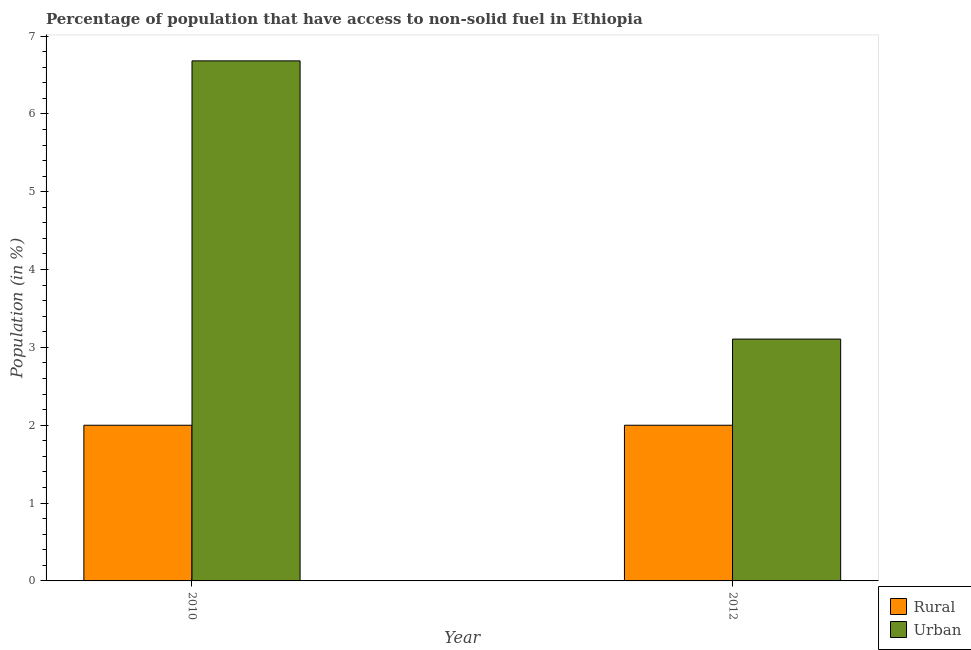How many groups of bars are there?
Offer a very short reply. 2. Are the number of bars per tick equal to the number of legend labels?
Keep it short and to the point. Yes. How many bars are there on the 2nd tick from the right?
Your response must be concise. 2. What is the urban population in 2010?
Offer a very short reply. 6.68. Across all years, what is the maximum rural population?
Provide a short and direct response. 2. Across all years, what is the minimum urban population?
Provide a succinct answer. 3.11. In which year was the rural population maximum?
Offer a terse response. 2010. What is the total urban population in the graph?
Offer a terse response. 9.79. What is the difference between the urban population in 2010 and that in 2012?
Keep it short and to the point. 3.57. What is the difference between the rural population in 2012 and the urban population in 2010?
Provide a short and direct response. 0. What is the average urban population per year?
Give a very brief answer. 4.89. In the year 2012, what is the difference between the rural population and urban population?
Your answer should be very brief. 0. What is the ratio of the urban population in 2010 to that in 2012?
Ensure brevity in your answer.  2.15. What does the 2nd bar from the left in 2012 represents?
Provide a succinct answer. Urban. What does the 1st bar from the right in 2010 represents?
Provide a succinct answer. Urban. Are all the bars in the graph horizontal?
Offer a terse response. No. Are the values on the major ticks of Y-axis written in scientific E-notation?
Provide a succinct answer. No. Does the graph contain grids?
Make the answer very short. No. Where does the legend appear in the graph?
Provide a succinct answer. Bottom right. How many legend labels are there?
Your answer should be compact. 2. How are the legend labels stacked?
Keep it short and to the point. Vertical. What is the title of the graph?
Your answer should be very brief. Percentage of population that have access to non-solid fuel in Ethiopia. What is the label or title of the Y-axis?
Provide a short and direct response. Population (in %). What is the Population (in %) in Rural in 2010?
Offer a terse response. 2. What is the Population (in %) in Urban in 2010?
Ensure brevity in your answer.  6.68. What is the Population (in %) in Rural in 2012?
Your answer should be very brief. 2. What is the Population (in %) in Urban in 2012?
Provide a succinct answer. 3.11. Across all years, what is the maximum Population (in %) in Rural?
Offer a very short reply. 2. Across all years, what is the maximum Population (in %) of Urban?
Offer a very short reply. 6.68. Across all years, what is the minimum Population (in %) in Rural?
Your answer should be very brief. 2. Across all years, what is the minimum Population (in %) of Urban?
Your answer should be compact. 3.11. What is the total Population (in %) in Urban in the graph?
Your answer should be very brief. 9.79. What is the difference between the Population (in %) of Rural in 2010 and that in 2012?
Keep it short and to the point. 0. What is the difference between the Population (in %) in Urban in 2010 and that in 2012?
Give a very brief answer. 3.57. What is the difference between the Population (in %) of Rural in 2010 and the Population (in %) of Urban in 2012?
Provide a short and direct response. -1.11. What is the average Population (in %) in Rural per year?
Offer a terse response. 2. What is the average Population (in %) in Urban per year?
Ensure brevity in your answer.  4.89. In the year 2010, what is the difference between the Population (in %) in Rural and Population (in %) in Urban?
Provide a short and direct response. -4.68. In the year 2012, what is the difference between the Population (in %) in Rural and Population (in %) in Urban?
Give a very brief answer. -1.11. What is the ratio of the Population (in %) of Urban in 2010 to that in 2012?
Offer a terse response. 2.15. What is the difference between the highest and the second highest Population (in %) of Urban?
Your response must be concise. 3.57. What is the difference between the highest and the lowest Population (in %) of Rural?
Give a very brief answer. 0. What is the difference between the highest and the lowest Population (in %) in Urban?
Provide a short and direct response. 3.57. 